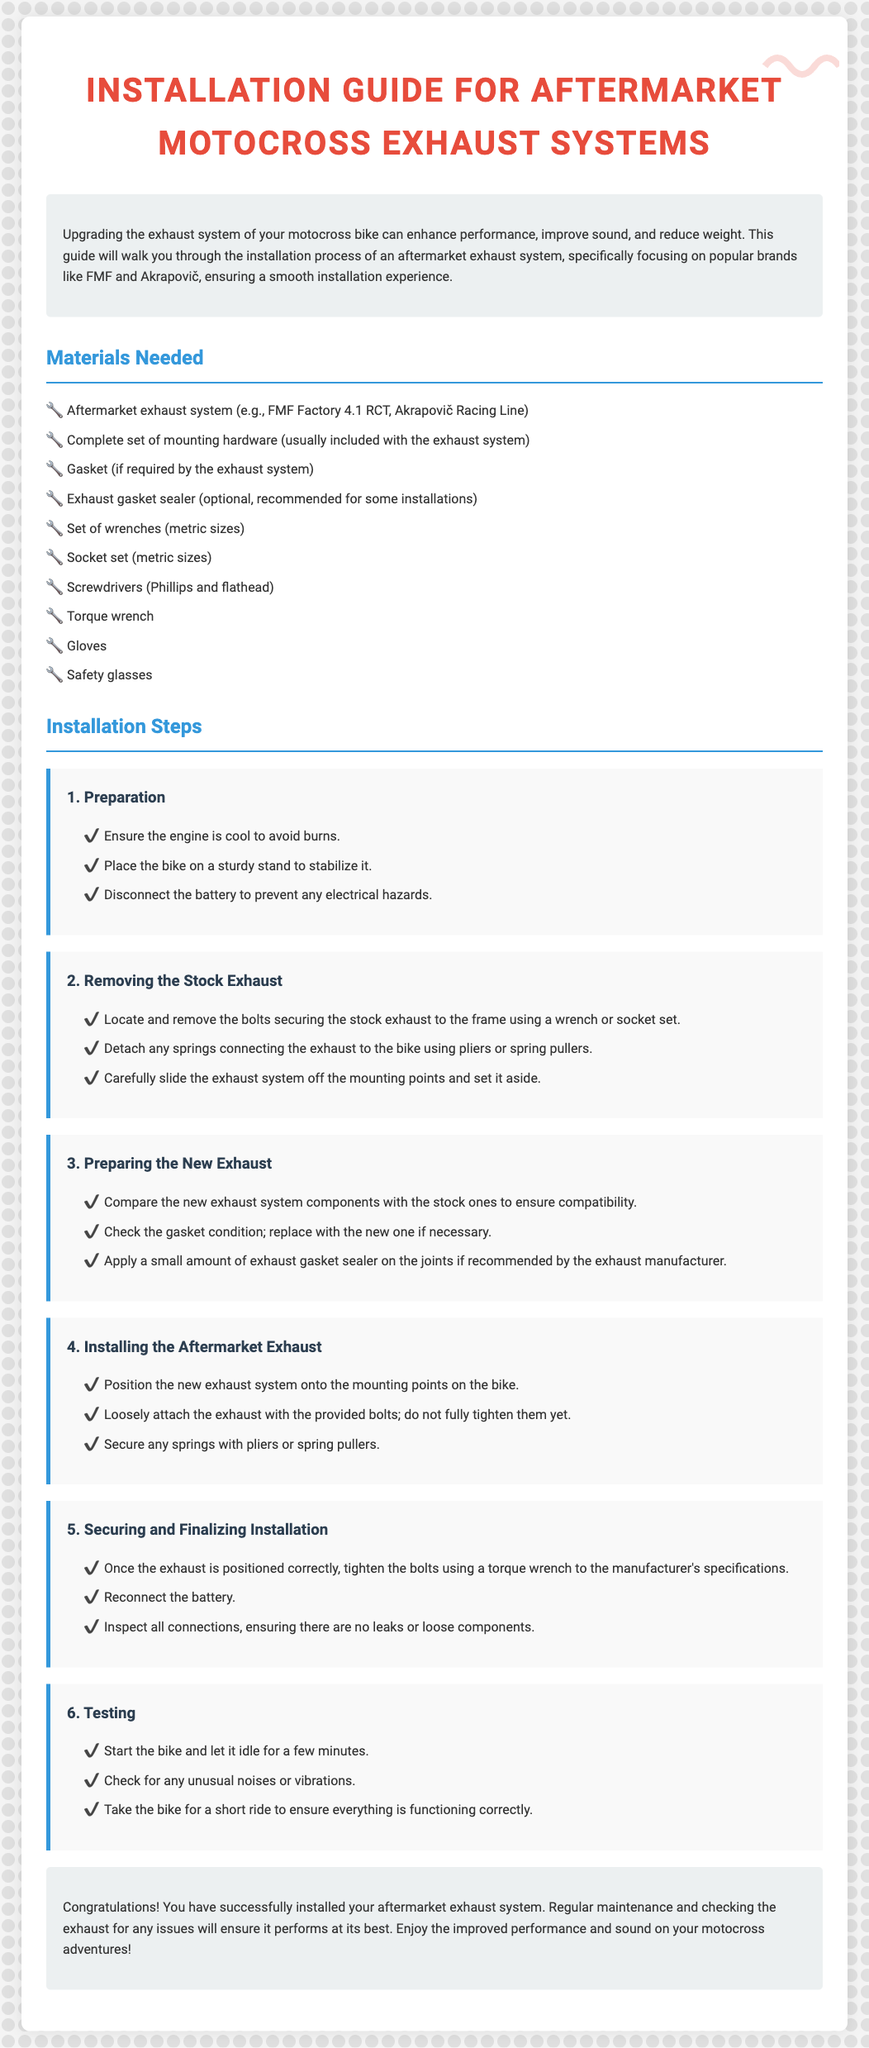What is the purpose of this guide? The introduction section outlines that upgrading the exhaust system can enhance performance, improve sound, and reduce weight.
Answer: Enhance performance What materials are required for the installation? The materials needed include various items listed in the section, such as an aftermarket exhaust system and a complete set of mounting hardware.
Answer: Aftermarket exhaust system, mounting hardware What is the first step in the installation process? The first step listed under Installation Steps is "Preparation," which includes ensuring the engine is cool and placing the bike on a sturdy stand.
Answer: Preparation How many steps are involved in installing the aftermarket exhaust? The document enumerates six specific steps involved in the installation process.
Answer: Six What should you do if the gasket is in poor condition? The third step advises to replace the gasket with a new one if necessary.
Answer: Replace it What is the final step after installing the exhaust? The last step in the installation process is "Testing," which involves starting the bike and checking for unusual noises.
Answer: Testing Which brands are mentioned as popular choices for aftermarket exhaust systems? The introduction specifies that FMF and Akrapovič are popular brands for aftermarket exhaust systems.
Answer: FMF, Akrapovič What tool is recommended for securing the bolts? It is advised to use a torque wrench for tightening the bolts to the manufacturer's specifications.
Answer: Torque wrench 